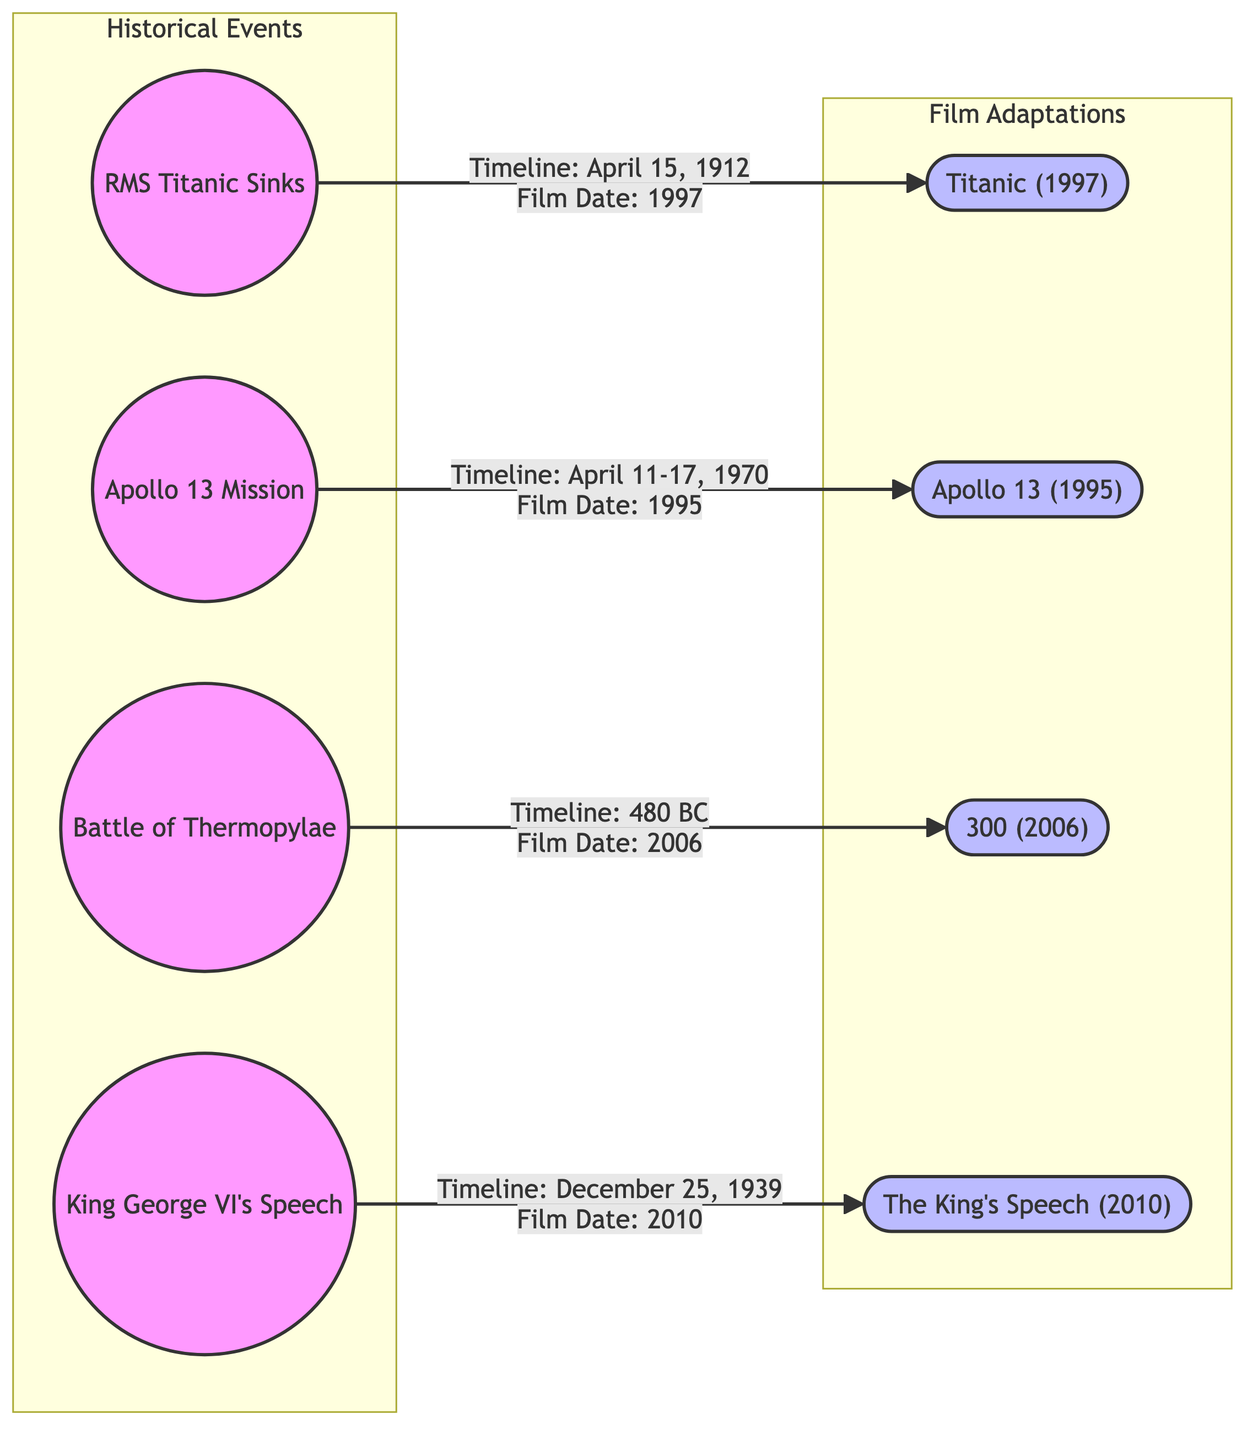What is the film adaptation for the event "RMS Titanic Sinks"? The diagram directly connects the real event "RMS Titanic Sinks" to the film adaptation "Titanic (1997)", indicating that this film represents the historical event depicted.
Answer: Titanic (1997) Which year did the "Apollo 13 Mission" take place? By looking at the timeline associated with the real event "Apollo 13 Mission" in the diagram, we can see that it occurred in April 1970.
Answer: 1970 How many total events are depicted in the diagram? The diagram shows a total of four historical events and their corresponding film adaptations. This can be counted by identifying each unique node representing either a real event or a film event.
Answer: 4 What is the timeline for the "Battle of Thermopylae"? The diagram specifies the timeline for the "Battle of Thermopylae" as 480 BC, which can be found in the annotation connected to the real event node.
Answer: 480 BC Which film adaptation corresponds to "King George VI's Speech"? Following the flow from the real event "King George VI's Speech," the diagram indicates that the corresponding film adaptation is "The King's Speech (2010)".
Answer: The King's Speech (2010) How many years passed between the historical event "RMS Titanic Sinks" and its film adaptation? The real event "RMS Titanic Sinks" happened in 1912, while the film "Titanic" was released in 1997. The difference between these years is calculated as 1997 - 1912, which equals 85 years.
Answer: 85 years What type of diagram is used to represent the relationship between historical events and films? The diagram is identified as a flowchart that illustrates the connections and discrepancies between historical events and their film adaptations.
Answer: Flowchart Which event occurred closest in time to its film adaptation? By comparing the timelines provided in the diagram, "Apollo 13 Mission" (1970) has a film adaptation released in 1995, resulting in a 25-year gap, while the others have larger gaps, making it the one with the least difference.
Answer: Apollo 13 Mission 